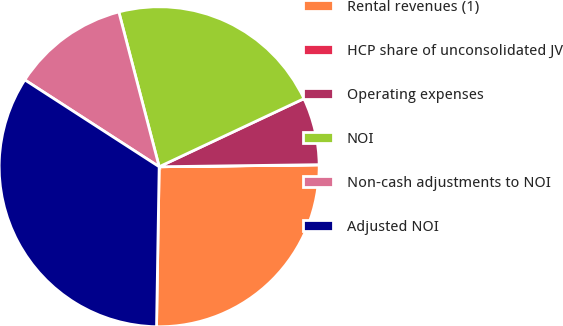Convert chart. <chart><loc_0><loc_0><loc_500><loc_500><pie_chart><fcel>Rental revenues (1)<fcel>HCP share of unconsolidated JV<fcel>Operating expenses<fcel>NOI<fcel>Non-cash adjustments to NOI<fcel>Adjusted NOI<nl><fcel>25.45%<fcel>0.02%<fcel>6.79%<fcel>22.06%<fcel>11.81%<fcel>33.87%<nl></chart> 